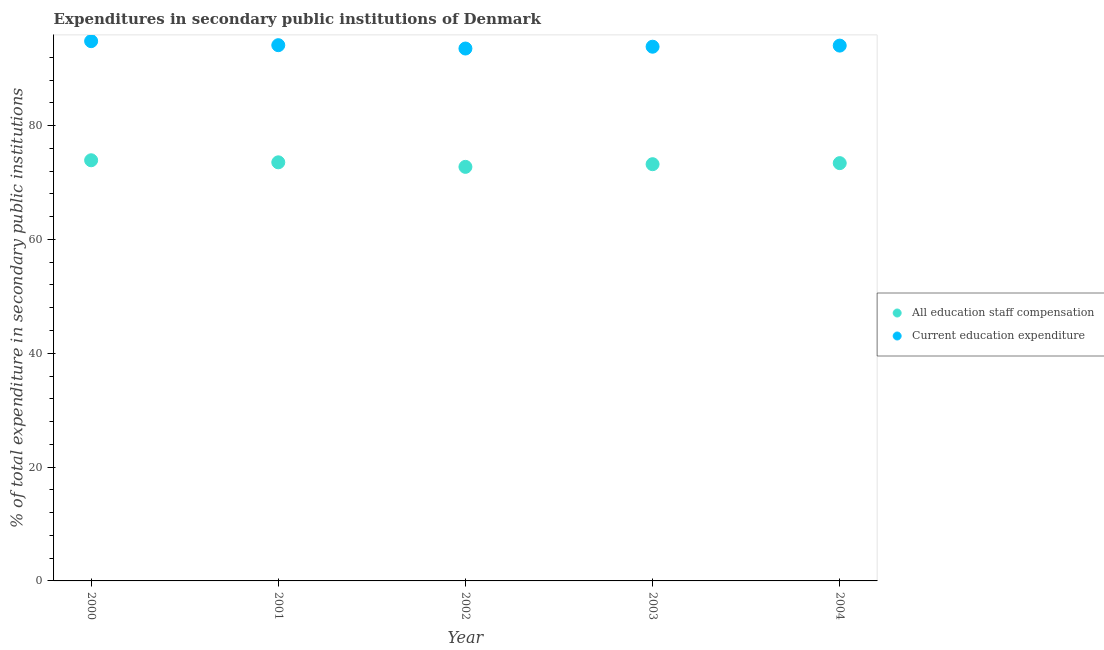Is the number of dotlines equal to the number of legend labels?
Your answer should be very brief. Yes. What is the expenditure in education in 2000?
Your response must be concise. 94.83. Across all years, what is the maximum expenditure in staff compensation?
Your answer should be compact. 73.9. Across all years, what is the minimum expenditure in education?
Ensure brevity in your answer.  93.53. In which year was the expenditure in education maximum?
Keep it short and to the point. 2000. In which year was the expenditure in education minimum?
Your response must be concise. 2002. What is the total expenditure in staff compensation in the graph?
Make the answer very short. 366.8. What is the difference between the expenditure in education in 2000 and that in 2003?
Provide a short and direct response. 0.97. What is the difference between the expenditure in education in 2003 and the expenditure in staff compensation in 2002?
Make the answer very short. 21.11. What is the average expenditure in staff compensation per year?
Your answer should be compact. 73.36. In the year 2004, what is the difference between the expenditure in staff compensation and expenditure in education?
Your answer should be compact. -20.65. What is the ratio of the expenditure in education in 2002 to that in 2004?
Your response must be concise. 0.99. Is the expenditure in education in 2001 less than that in 2004?
Your answer should be very brief. No. What is the difference between the highest and the second highest expenditure in education?
Keep it short and to the point. 0.71. What is the difference between the highest and the lowest expenditure in education?
Your response must be concise. 1.29. Is the sum of the expenditure in staff compensation in 2003 and 2004 greater than the maximum expenditure in education across all years?
Give a very brief answer. Yes. How many dotlines are there?
Your answer should be compact. 2. Are the values on the major ticks of Y-axis written in scientific E-notation?
Give a very brief answer. No. Does the graph contain grids?
Keep it short and to the point. No. How many legend labels are there?
Offer a terse response. 2. How are the legend labels stacked?
Make the answer very short. Vertical. What is the title of the graph?
Give a very brief answer. Expenditures in secondary public institutions of Denmark. What is the label or title of the Y-axis?
Keep it short and to the point. % of total expenditure in secondary public institutions. What is the % of total expenditure in secondary public institutions of All education staff compensation in 2000?
Your answer should be compact. 73.9. What is the % of total expenditure in secondary public institutions in Current education expenditure in 2000?
Make the answer very short. 94.83. What is the % of total expenditure in secondary public institutions of All education staff compensation in 2001?
Provide a short and direct response. 73.54. What is the % of total expenditure in secondary public institutions of Current education expenditure in 2001?
Offer a very short reply. 94.12. What is the % of total expenditure in secondary public institutions in All education staff compensation in 2002?
Your answer should be very brief. 72.74. What is the % of total expenditure in secondary public institutions of Current education expenditure in 2002?
Make the answer very short. 93.53. What is the % of total expenditure in secondary public institutions of All education staff compensation in 2003?
Provide a short and direct response. 73.21. What is the % of total expenditure in secondary public institutions of Current education expenditure in 2003?
Your response must be concise. 93.85. What is the % of total expenditure in secondary public institutions in All education staff compensation in 2004?
Provide a succinct answer. 73.4. What is the % of total expenditure in secondary public institutions of Current education expenditure in 2004?
Your answer should be very brief. 94.05. Across all years, what is the maximum % of total expenditure in secondary public institutions in All education staff compensation?
Provide a short and direct response. 73.9. Across all years, what is the maximum % of total expenditure in secondary public institutions of Current education expenditure?
Your answer should be very brief. 94.83. Across all years, what is the minimum % of total expenditure in secondary public institutions of All education staff compensation?
Provide a succinct answer. 72.74. Across all years, what is the minimum % of total expenditure in secondary public institutions in Current education expenditure?
Give a very brief answer. 93.53. What is the total % of total expenditure in secondary public institutions in All education staff compensation in the graph?
Give a very brief answer. 366.8. What is the total % of total expenditure in secondary public institutions of Current education expenditure in the graph?
Your answer should be very brief. 470.38. What is the difference between the % of total expenditure in secondary public institutions in All education staff compensation in 2000 and that in 2001?
Your answer should be compact. 0.36. What is the difference between the % of total expenditure in secondary public institutions in Current education expenditure in 2000 and that in 2001?
Your answer should be compact. 0.71. What is the difference between the % of total expenditure in secondary public institutions in All education staff compensation in 2000 and that in 2002?
Give a very brief answer. 1.16. What is the difference between the % of total expenditure in secondary public institutions in Current education expenditure in 2000 and that in 2002?
Provide a succinct answer. 1.29. What is the difference between the % of total expenditure in secondary public institutions in All education staff compensation in 2000 and that in 2003?
Your response must be concise. 0.69. What is the difference between the % of total expenditure in secondary public institutions in Current education expenditure in 2000 and that in 2003?
Offer a very short reply. 0.97. What is the difference between the % of total expenditure in secondary public institutions in All education staff compensation in 2000 and that in 2004?
Keep it short and to the point. 0.5. What is the difference between the % of total expenditure in secondary public institutions in Current education expenditure in 2000 and that in 2004?
Your answer should be very brief. 0.78. What is the difference between the % of total expenditure in secondary public institutions of All education staff compensation in 2001 and that in 2002?
Provide a short and direct response. 0.8. What is the difference between the % of total expenditure in secondary public institutions in Current education expenditure in 2001 and that in 2002?
Offer a terse response. 0.59. What is the difference between the % of total expenditure in secondary public institutions in All education staff compensation in 2001 and that in 2003?
Ensure brevity in your answer.  0.33. What is the difference between the % of total expenditure in secondary public institutions of Current education expenditure in 2001 and that in 2003?
Your answer should be compact. 0.27. What is the difference between the % of total expenditure in secondary public institutions in All education staff compensation in 2001 and that in 2004?
Provide a succinct answer. 0.14. What is the difference between the % of total expenditure in secondary public institutions of Current education expenditure in 2001 and that in 2004?
Your response must be concise. 0.08. What is the difference between the % of total expenditure in secondary public institutions of All education staff compensation in 2002 and that in 2003?
Give a very brief answer. -0.47. What is the difference between the % of total expenditure in secondary public institutions of Current education expenditure in 2002 and that in 2003?
Your response must be concise. -0.32. What is the difference between the % of total expenditure in secondary public institutions of All education staff compensation in 2002 and that in 2004?
Keep it short and to the point. -0.65. What is the difference between the % of total expenditure in secondary public institutions of Current education expenditure in 2002 and that in 2004?
Ensure brevity in your answer.  -0.51. What is the difference between the % of total expenditure in secondary public institutions in All education staff compensation in 2003 and that in 2004?
Keep it short and to the point. -0.19. What is the difference between the % of total expenditure in secondary public institutions of Current education expenditure in 2003 and that in 2004?
Your answer should be compact. -0.19. What is the difference between the % of total expenditure in secondary public institutions of All education staff compensation in 2000 and the % of total expenditure in secondary public institutions of Current education expenditure in 2001?
Make the answer very short. -20.22. What is the difference between the % of total expenditure in secondary public institutions of All education staff compensation in 2000 and the % of total expenditure in secondary public institutions of Current education expenditure in 2002?
Keep it short and to the point. -19.63. What is the difference between the % of total expenditure in secondary public institutions in All education staff compensation in 2000 and the % of total expenditure in secondary public institutions in Current education expenditure in 2003?
Keep it short and to the point. -19.95. What is the difference between the % of total expenditure in secondary public institutions in All education staff compensation in 2000 and the % of total expenditure in secondary public institutions in Current education expenditure in 2004?
Your answer should be very brief. -20.14. What is the difference between the % of total expenditure in secondary public institutions of All education staff compensation in 2001 and the % of total expenditure in secondary public institutions of Current education expenditure in 2002?
Your answer should be very brief. -19.99. What is the difference between the % of total expenditure in secondary public institutions of All education staff compensation in 2001 and the % of total expenditure in secondary public institutions of Current education expenditure in 2003?
Provide a short and direct response. -20.31. What is the difference between the % of total expenditure in secondary public institutions of All education staff compensation in 2001 and the % of total expenditure in secondary public institutions of Current education expenditure in 2004?
Give a very brief answer. -20.5. What is the difference between the % of total expenditure in secondary public institutions of All education staff compensation in 2002 and the % of total expenditure in secondary public institutions of Current education expenditure in 2003?
Offer a terse response. -21.11. What is the difference between the % of total expenditure in secondary public institutions of All education staff compensation in 2002 and the % of total expenditure in secondary public institutions of Current education expenditure in 2004?
Your answer should be compact. -21.3. What is the difference between the % of total expenditure in secondary public institutions in All education staff compensation in 2003 and the % of total expenditure in secondary public institutions in Current education expenditure in 2004?
Provide a succinct answer. -20.83. What is the average % of total expenditure in secondary public institutions in All education staff compensation per year?
Your answer should be very brief. 73.36. What is the average % of total expenditure in secondary public institutions in Current education expenditure per year?
Your answer should be compact. 94.08. In the year 2000, what is the difference between the % of total expenditure in secondary public institutions in All education staff compensation and % of total expenditure in secondary public institutions in Current education expenditure?
Offer a terse response. -20.93. In the year 2001, what is the difference between the % of total expenditure in secondary public institutions in All education staff compensation and % of total expenditure in secondary public institutions in Current education expenditure?
Ensure brevity in your answer.  -20.58. In the year 2002, what is the difference between the % of total expenditure in secondary public institutions of All education staff compensation and % of total expenditure in secondary public institutions of Current education expenditure?
Your response must be concise. -20.79. In the year 2003, what is the difference between the % of total expenditure in secondary public institutions of All education staff compensation and % of total expenditure in secondary public institutions of Current education expenditure?
Ensure brevity in your answer.  -20.64. In the year 2004, what is the difference between the % of total expenditure in secondary public institutions in All education staff compensation and % of total expenditure in secondary public institutions in Current education expenditure?
Your response must be concise. -20.65. What is the ratio of the % of total expenditure in secondary public institutions in All education staff compensation in 2000 to that in 2001?
Provide a short and direct response. 1. What is the ratio of the % of total expenditure in secondary public institutions in Current education expenditure in 2000 to that in 2001?
Offer a very short reply. 1.01. What is the ratio of the % of total expenditure in secondary public institutions of All education staff compensation in 2000 to that in 2002?
Offer a terse response. 1.02. What is the ratio of the % of total expenditure in secondary public institutions in Current education expenditure in 2000 to that in 2002?
Provide a short and direct response. 1.01. What is the ratio of the % of total expenditure in secondary public institutions of All education staff compensation in 2000 to that in 2003?
Keep it short and to the point. 1.01. What is the ratio of the % of total expenditure in secondary public institutions in Current education expenditure in 2000 to that in 2003?
Keep it short and to the point. 1.01. What is the ratio of the % of total expenditure in secondary public institutions in Current education expenditure in 2000 to that in 2004?
Your answer should be very brief. 1.01. What is the ratio of the % of total expenditure in secondary public institutions in Current education expenditure in 2001 to that in 2002?
Provide a short and direct response. 1.01. What is the ratio of the % of total expenditure in secondary public institutions in Current education expenditure in 2001 to that in 2003?
Give a very brief answer. 1. What is the ratio of the % of total expenditure in secondary public institutions in All education staff compensation in 2002 to that in 2003?
Offer a terse response. 0.99. What is the ratio of the % of total expenditure in secondary public institutions of Current education expenditure in 2002 to that in 2003?
Make the answer very short. 1. What is the ratio of the % of total expenditure in secondary public institutions of All education staff compensation in 2002 to that in 2004?
Your answer should be compact. 0.99. What is the ratio of the % of total expenditure in secondary public institutions in All education staff compensation in 2003 to that in 2004?
Keep it short and to the point. 1. What is the difference between the highest and the second highest % of total expenditure in secondary public institutions of All education staff compensation?
Provide a succinct answer. 0.36. What is the difference between the highest and the second highest % of total expenditure in secondary public institutions in Current education expenditure?
Offer a terse response. 0.71. What is the difference between the highest and the lowest % of total expenditure in secondary public institutions in All education staff compensation?
Provide a short and direct response. 1.16. What is the difference between the highest and the lowest % of total expenditure in secondary public institutions in Current education expenditure?
Keep it short and to the point. 1.29. 